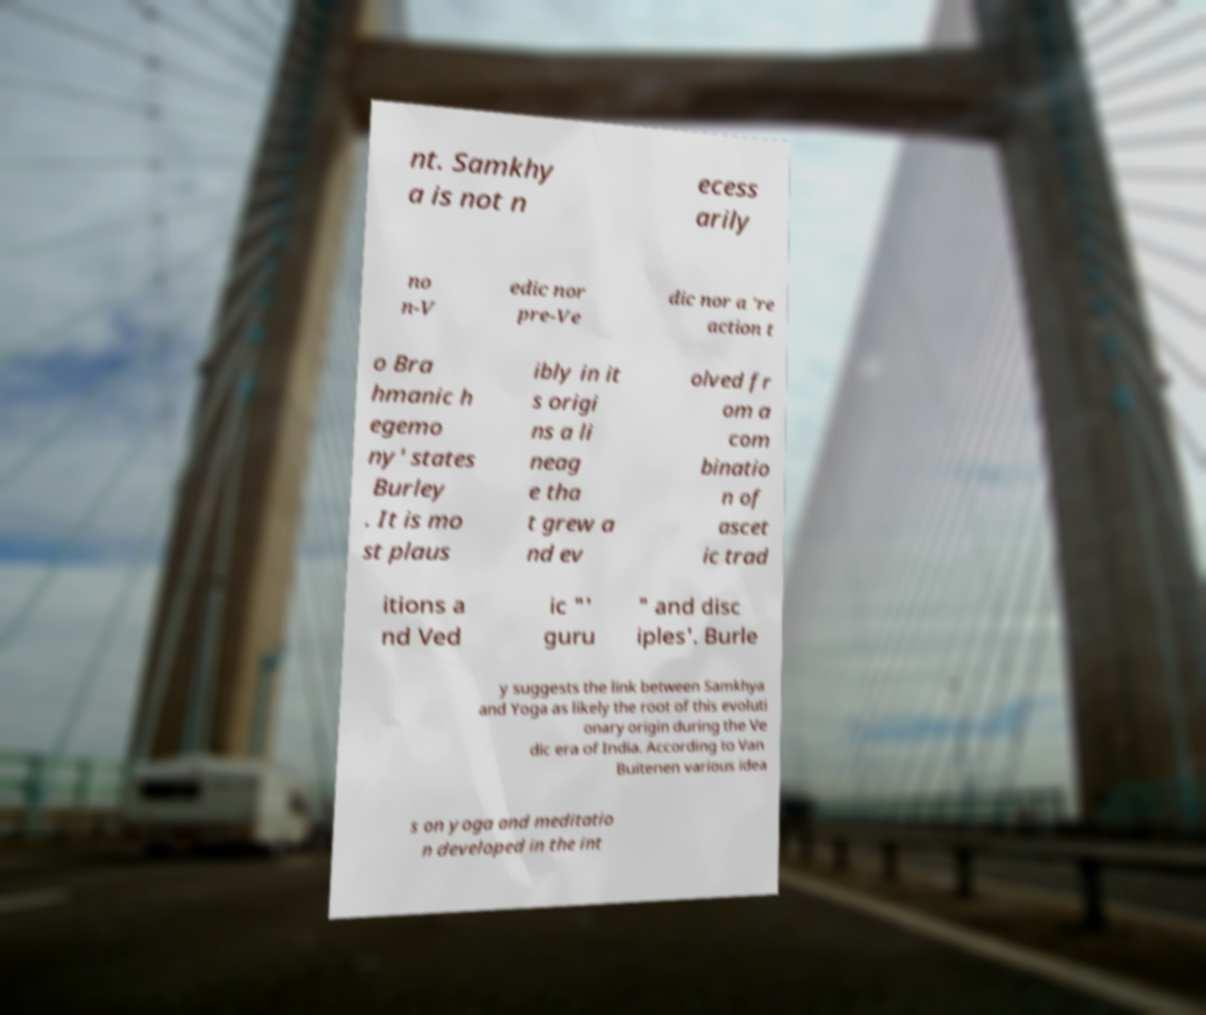I need the written content from this picture converted into text. Can you do that? nt. Samkhy a is not n ecess arily no n-V edic nor pre-Ve dic nor a 're action t o Bra hmanic h egemo ny' states Burley . It is mo st plaus ibly in it s origi ns a li neag e tha t grew a nd ev olved fr om a com binatio n of ascet ic trad itions a nd Ved ic "' guru " and disc iples'. Burle y suggests the link between Samkhya and Yoga as likely the root of this evoluti onary origin during the Ve dic era of India. According to Van Buitenen various idea s on yoga and meditatio n developed in the int 